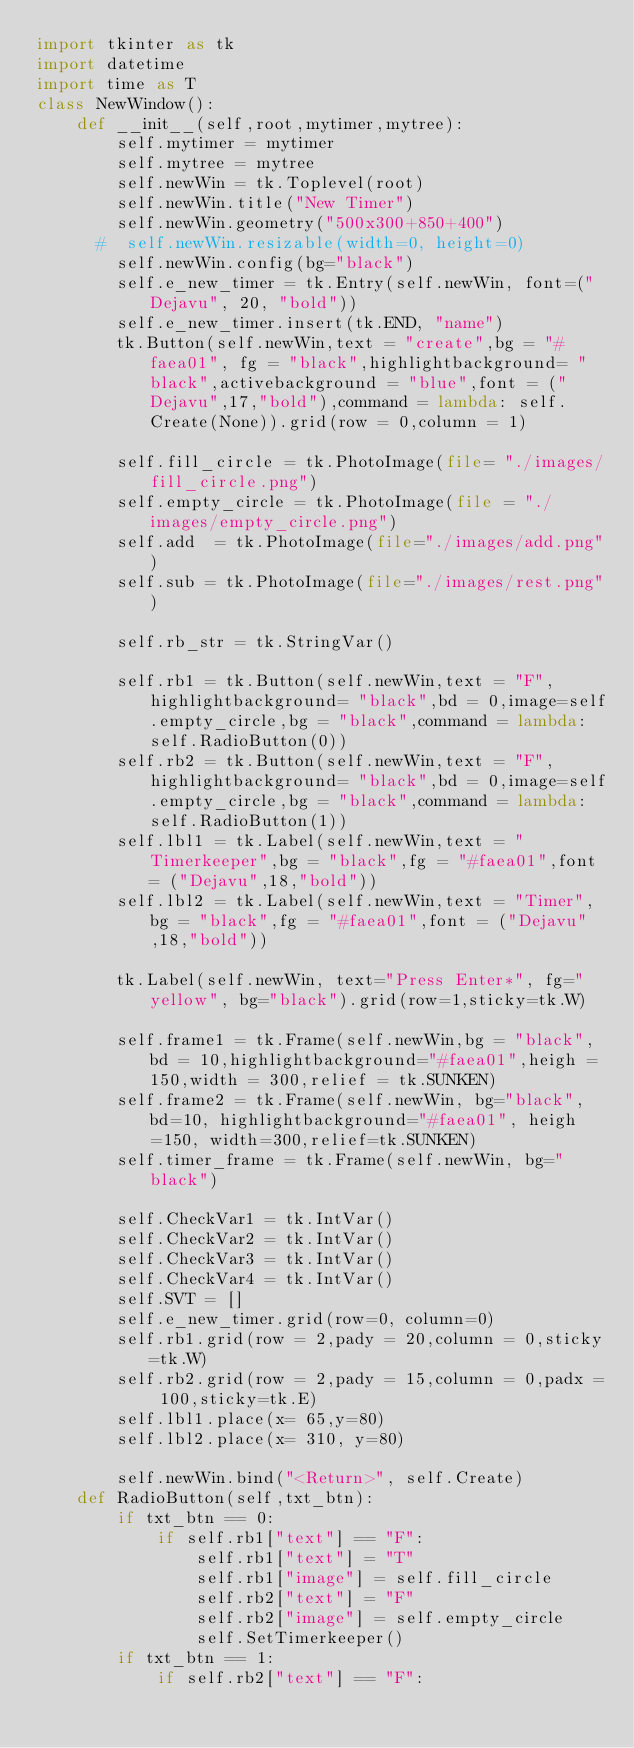Convert code to text. <code><loc_0><loc_0><loc_500><loc_500><_Python_>import tkinter as tk
import datetime
import time as T
class NewWindow():
    def __init__(self,root,mytimer,mytree):
        self.mytimer = mytimer
        self.mytree = mytree
        self.newWin = tk.Toplevel(root)
        self.newWin.title("New Timer")
        self.newWin.geometry("500x300+850+400")
      #  self.newWin.resizable(width=0, height=0)
        self.newWin.config(bg="black")
        self.e_new_timer = tk.Entry(self.newWin, font=("Dejavu", 20, "bold"))
        self.e_new_timer.insert(tk.END, "name")
        tk.Button(self.newWin,text = "create",bg = "#faea01", fg = "black",highlightbackground= "black",activebackground = "blue",font = ("Dejavu",17,"bold"),command = lambda: self.Create(None)).grid(row = 0,column = 1)

        self.fill_circle = tk.PhotoImage(file= "./images/fill_circle.png")
        self.empty_circle = tk.PhotoImage(file = "./images/empty_circle.png")
        self.add  = tk.PhotoImage(file="./images/add.png")
        self.sub = tk.PhotoImage(file="./images/rest.png")

        self.rb_str = tk.StringVar()

        self.rb1 = tk.Button(self.newWin,text = "F",highlightbackground= "black",bd = 0,image=self.empty_circle,bg = "black",command = lambda:self.RadioButton(0))
        self.rb2 = tk.Button(self.newWin,text = "F",highlightbackground= "black",bd = 0,image=self.empty_circle,bg = "black",command = lambda:self.RadioButton(1))
        self.lbl1 = tk.Label(self.newWin,text = "Timerkeeper",bg = "black",fg = "#faea01",font = ("Dejavu",18,"bold"))
        self.lbl2 = tk.Label(self.newWin,text = "Timer",bg = "black",fg = "#faea01",font = ("Dejavu",18,"bold"))

        tk.Label(self.newWin, text="Press Enter*", fg="yellow", bg="black").grid(row=1,sticky=tk.W)

        self.frame1 = tk.Frame(self.newWin,bg = "black",bd = 10,highlightbackground="#faea01",heigh = 150,width = 300,relief = tk.SUNKEN)
        self.frame2 = tk.Frame(self.newWin, bg="black", bd=10, highlightbackground="#faea01", heigh=150, width=300,relief=tk.SUNKEN)
        self.timer_frame = tk.Frame(self.newWin, bg="black")

        self.CheckVar1 = tk.IntVar()
        self.CheckVar2 = tk.IntVar()
        self.CheckVar3 = tk.IntVar()
        self.CheckVar4 = tk.IntVar()
        self.SVT = []
        self.e_new_timer.grid(row=0, column=0)
        self.rb1.grid(row = 2,pady = 20,column = 0,sticky=tk.W)
        self.rb2.grid(row = 2,pady = 15,column = 0,padx = 100,sticky=tk.E)
        self.lbl1.place(x= 65,y=80)
        self.lbl2.place(x= 310, y=80)

        self.newWin.bind("<Return>", self.Create)
    def RadioButton(self,txt_btn):
        if txt_btn == 0:
            if self.rb1["text"] == "F":
                self.rb1["text"] = "T"
                self.rb1["image"] = self.fill_circle
                self.rb2["text"] = "F"
                self.rb2["image"] = self.empty_circle
                self.SetTimerkeeper()
        if txt_btn == 1:
            if self.rb2["text"] == "F":</code> 